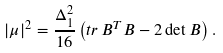<formula> <loc_0><loc_0><loc_500><loc_500>| \mu | ^ { 2 } = \frac { \Delta _ { 1 } ^ { 2 } } { 1 6 } \left ( t r \, B ^ { T } B - 2 \det B \right ) .</formula> 